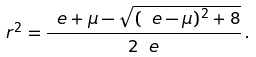<formula> <loc_0><loc_0><loc_500><loc_500>r ^ { 2 } = \frac { \ e + \mu - \sqrt { ( \ e - \mu ) ^ { 2 } + 8 } } { 2 \ e } \, .</formula> 